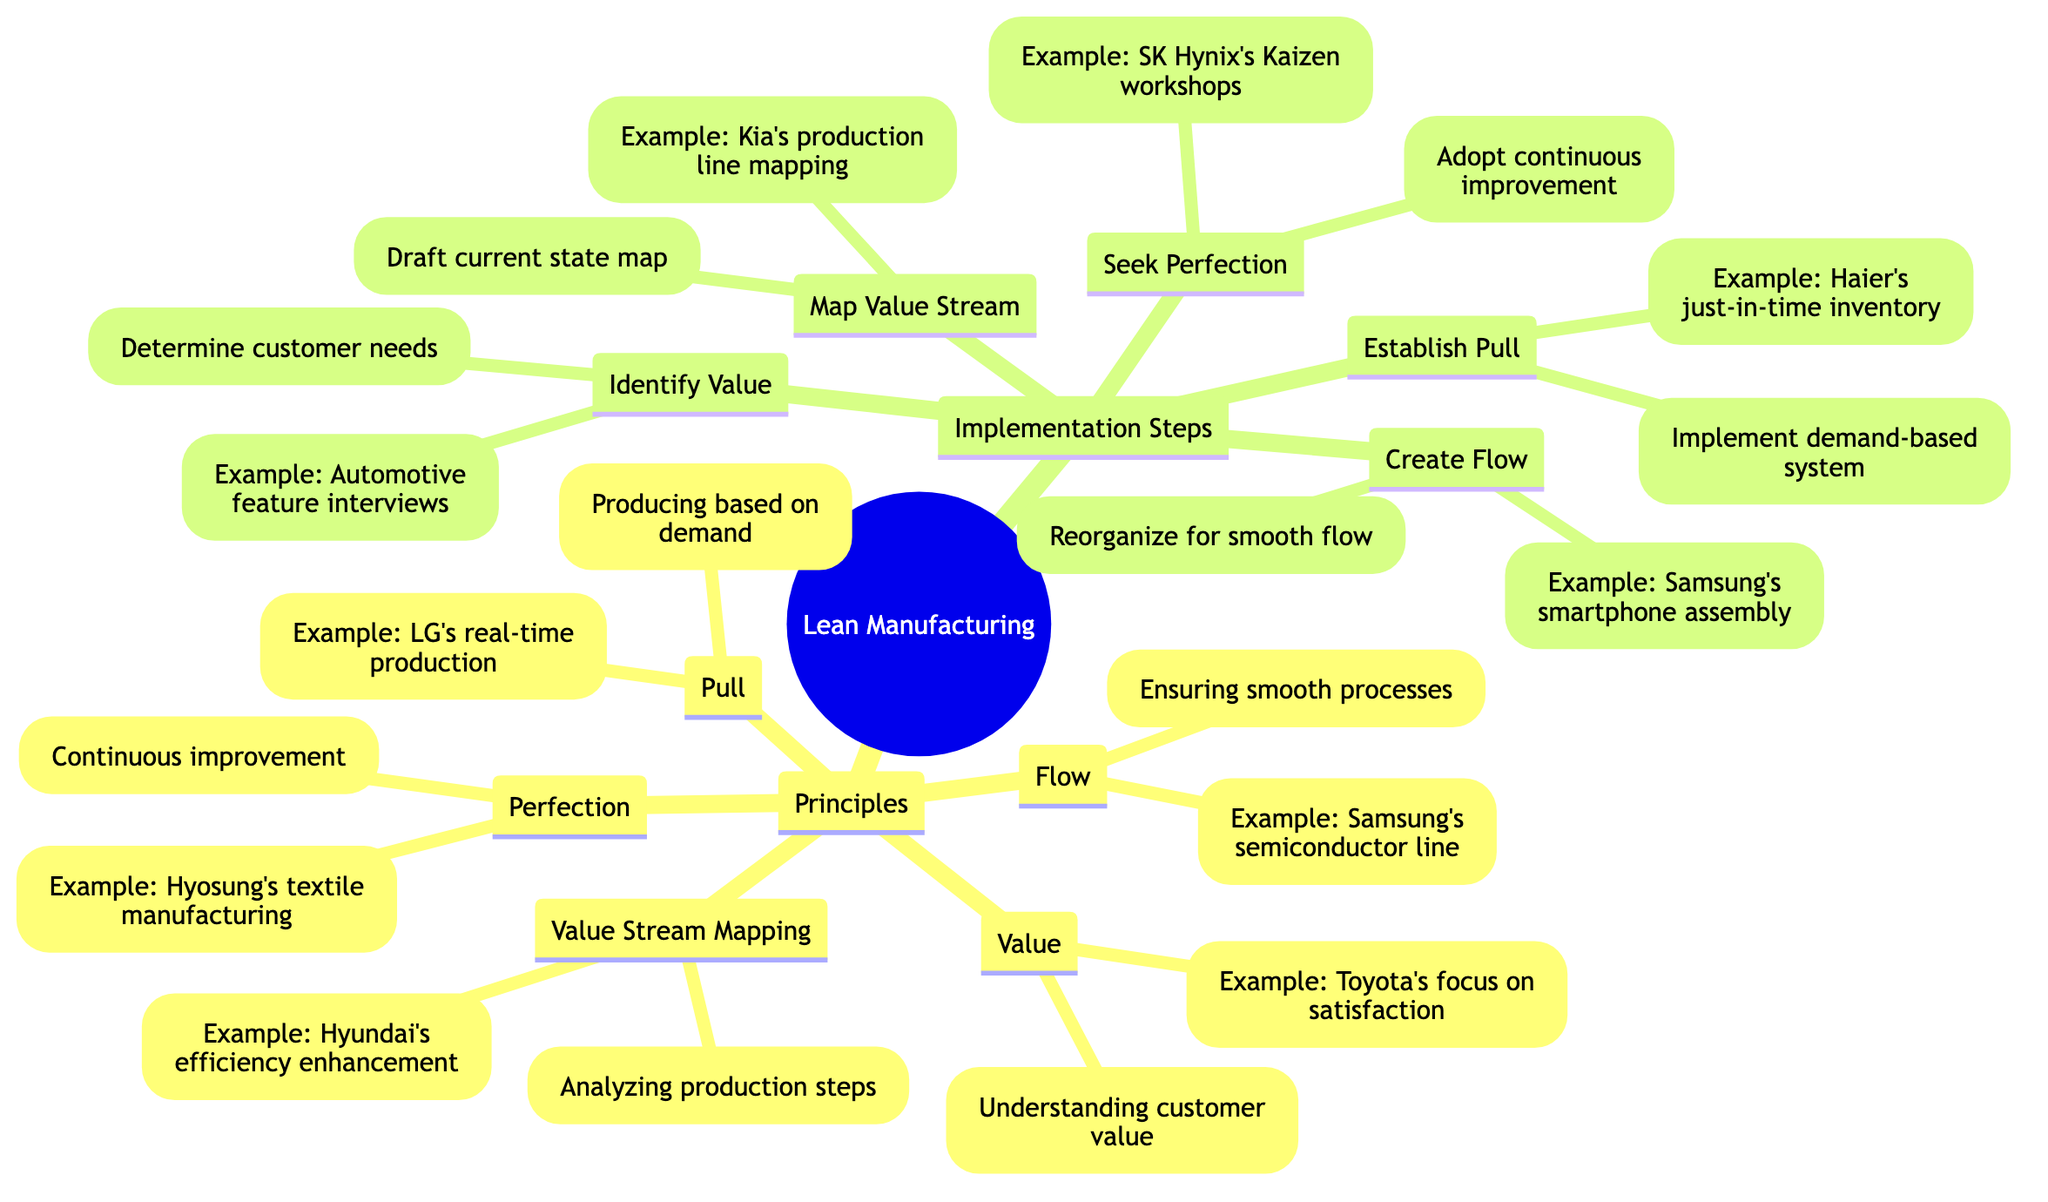What is the definition of Pull? Pull is defined in the diagram as "Producing only what is needed by the customer, thereby reducing inventory costs."
Answer: Producing only what is needed by the customer, thereby reducing inventory costs How many principles are listed in the diagram? The diagram shows five principles under Lean Manufacturing: Value, Value Stream Mapping, Flow, Pull, and Perfection. Thus, the total number of principles is five.
Answer: Five What action is associated with Seek Perfection? The action associated with Seek Perfection is "Adopt continuous improvement practices to eliminate waste and enhance quality."
Answer: Adopt continuous improvement practices to eliminate waste and enhance quality Which company is mentioned as applying flow in their manufacturing process? Samsung is mentioned as applying the concept of flow in their semiconductor manufacturing line to eliminate bottlenecks.
Answer: Samsung What does Value Stream Mapping aim to analyze? Value Stream Mapping aims to analyze "the series of steps that occur to bring a product from its inception to delivery."
Answer: The series of steps that occur to bring a product from its inception to delivery What is the main goal of the Lean Manufacturing principles? The main goal is described in the principle of Perfection, stating "Aiming for continuous improvement in all processes and striving for zero defects."
Answer: Aiming for continuous improvement in all processes and striving for zero defects Which implementation step comes after Create Flow? The step that comes after Create Flow is "Establish Pull." The flow is sequential in the implementation steps.
Answer: Establish Pull What example illustrates the implementation of Identify Value? Interviewing end-users to understand their needs in automotive features is the example given for identifying value.
Answer: Interviewing end-users to understand their needs in automotive features What does the diagram suggest is a characteristic of Lean Manufacturing? One characteristic of Lean Manufacturing suggested in the diagram is its focus on eliminating waste, particularly through continuous improvement practices highlighted in Seek Perfection.
Answer: Eliminating waste 